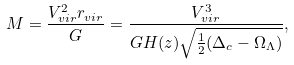Convert formula to latex. <formula><loc_0><loc_0><loc_500><loc_500>M = \frac { V _ { v i r } ^ { 2 } r _ { v i r } } { G } = \frac { V _ { v i r } ^ { 3 } } { G H ( z ) \sqrt { \frac { 1 } { 2 } ( \Delta _ { c } - \Omega _ { \Lambda } ) } } ,</formula> 